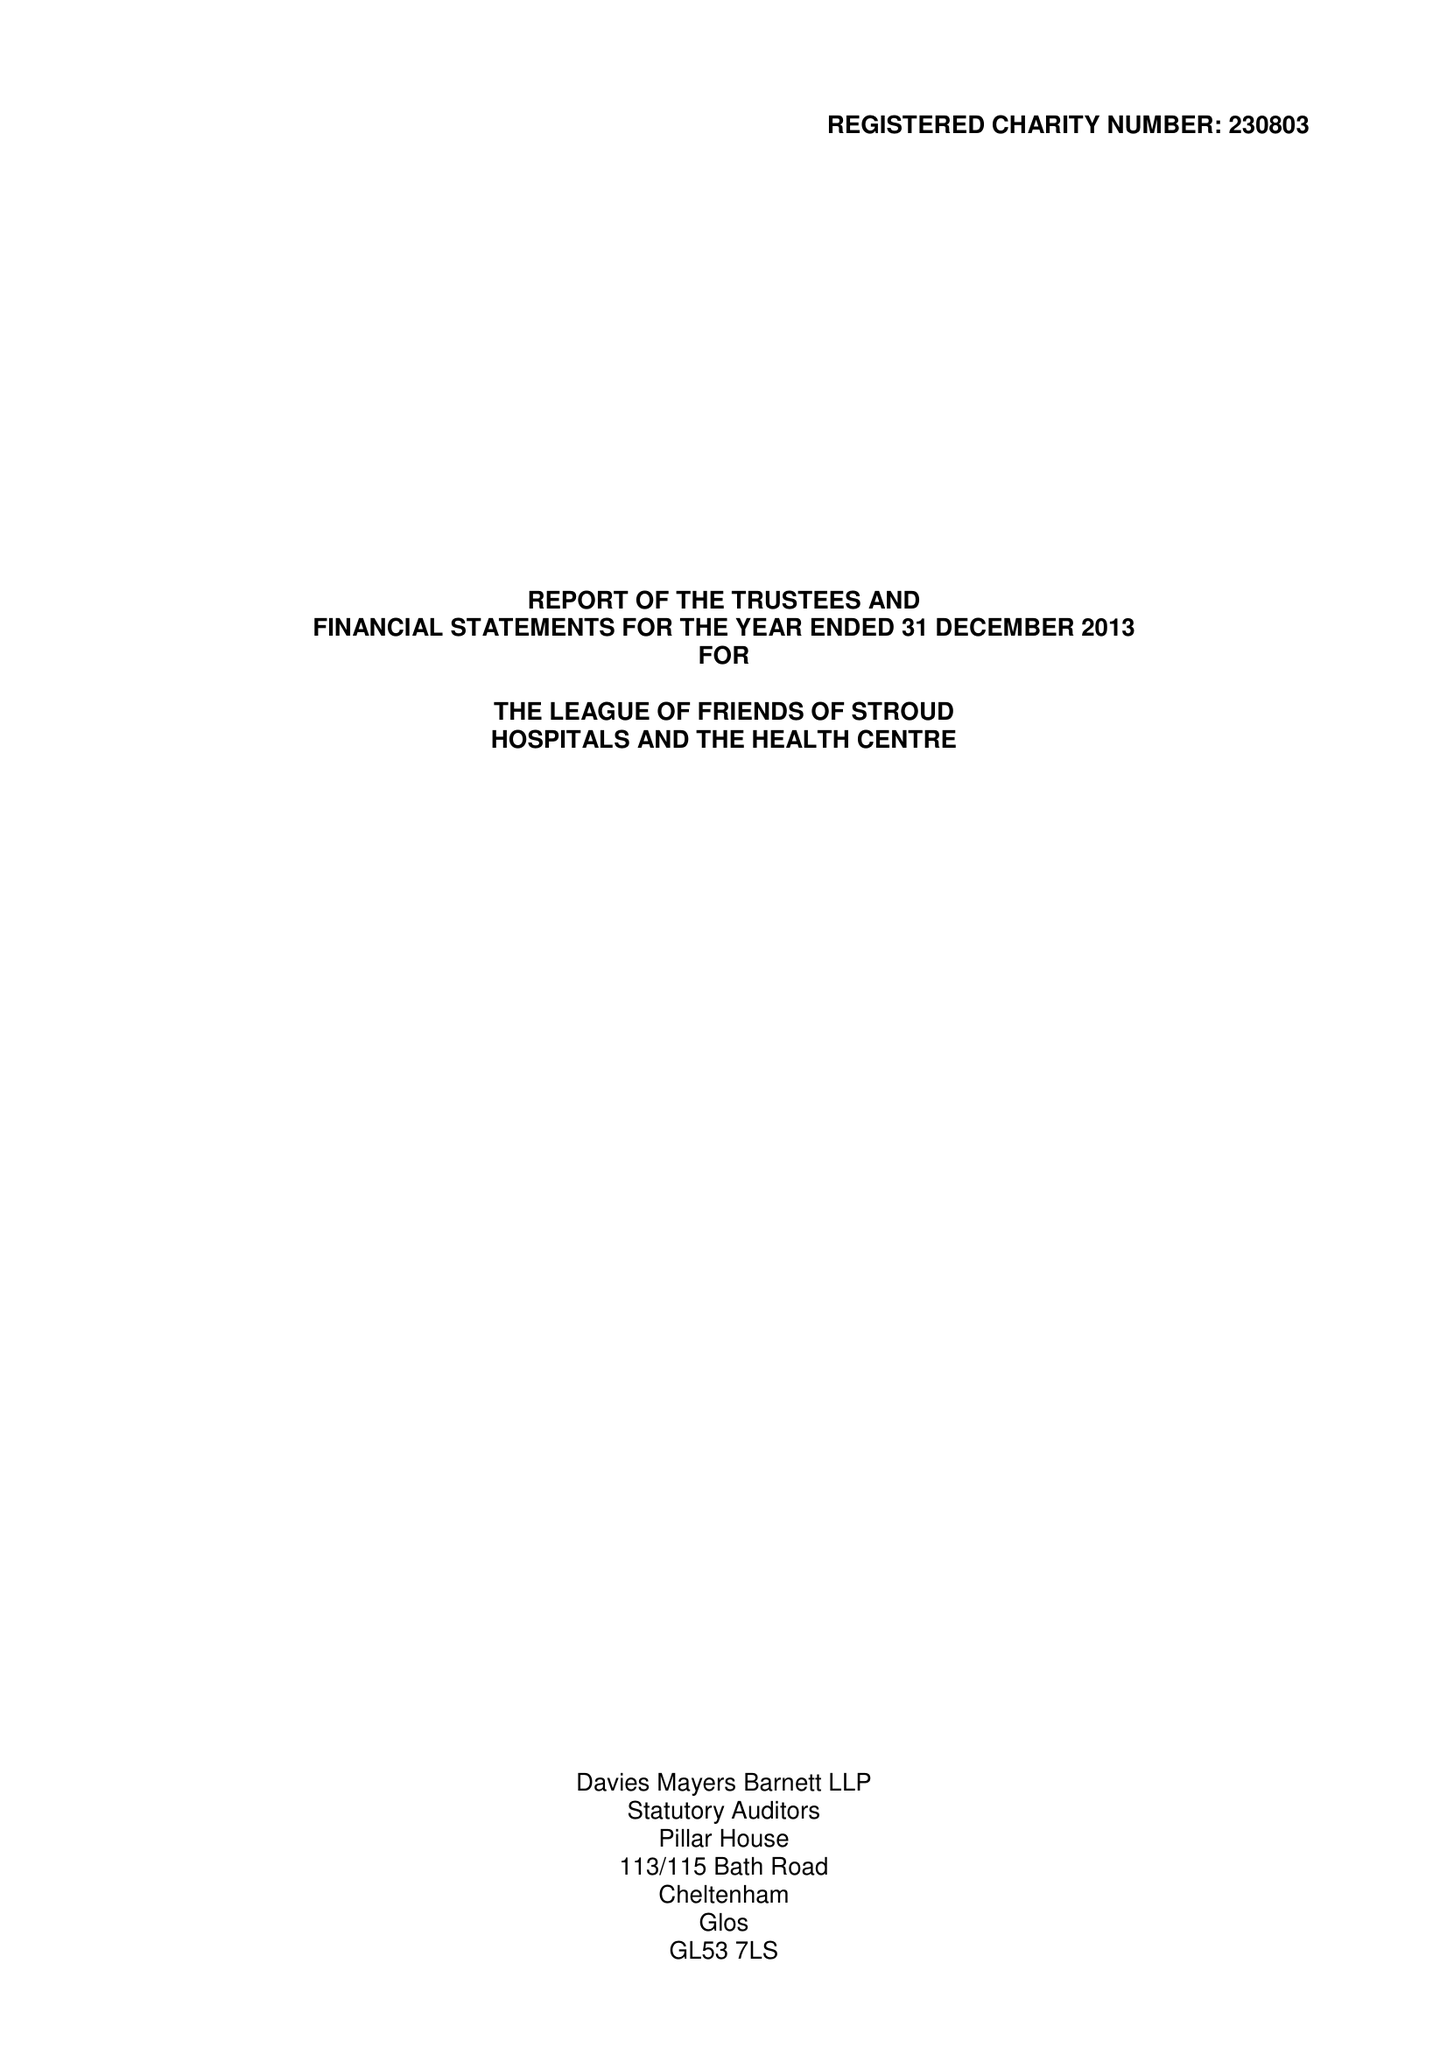What is the value for the spending_annually_in_british_pounds?
Answer the question using a single word or phrase. 61574.00 